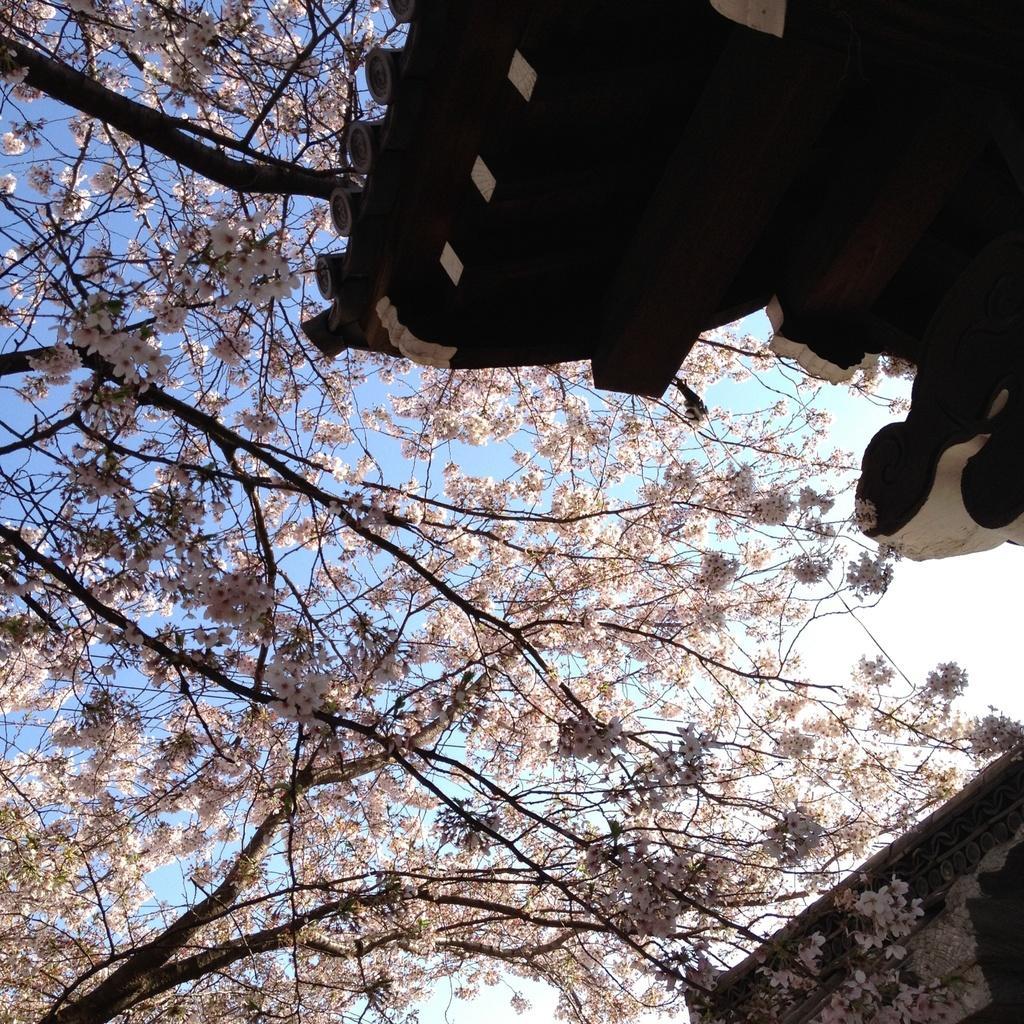Describe this image in one or two sentences. In this picture we can see trees. On the top right corner there is a roof of the building. On the bottom right there is a house. In the background we can see sky and clouds. 